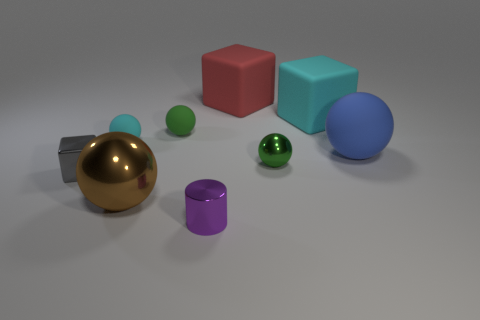There is a big block that is to the right of the large cube left of the big cyan matte block; are there any purple metal things in front of it?
Offer a terse response. Yes. There is a shiny object that is the same size as the red matte cube; what color is it?
Provide a short and direct response. Brown. The metal object that is both on the left side of the small green matte sphere and in front of the tiny gray metallic cube has what shape?
Keep it short and to the point. Sphere. There is a green ball that is behind the green ball that is in front of the blue ball; what size is it?
Provide a succinct answer. Small. How many other spheres are the same color as the tiny shiny sphere?
Provide a succinct answer. 1. What number of other things are there of the same size as the cyan block?
Offer a terse response. 3. What size is the block that is both left of the cyan matte cube and to the right of the small gray object?
Offer a terse response. Large. What number of other large blue matte objects have the same shape as the blue matte object?
Give a very brief answer. 0. What material is the tiny purple object?
Provide a short and direct response. Metal. Do the tiny green matte thing and the large red rubber thing have the same shape?
Keep it short and to the point. No. 